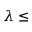Convert formula to latex. <formula><loc_0><loc_0><loc_500><loc_500>\lambda \leq</formula> 